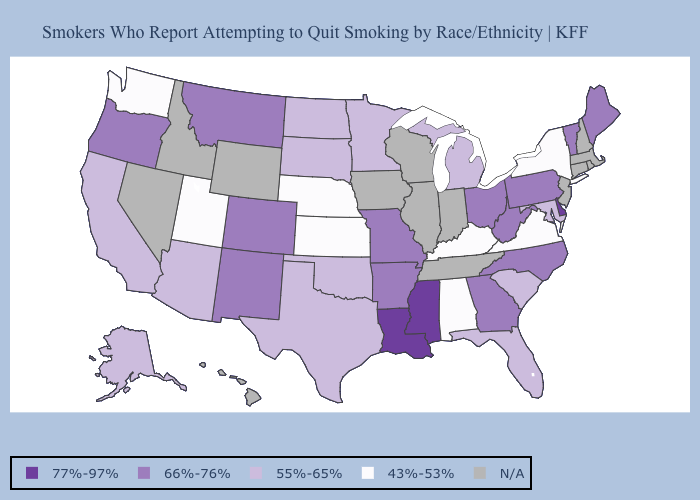Name the states that have a value in the range 66%-76%?
Answer briefly. Arkansas, Colorado, Georgia, Maine, Missouri, Montana, New Mexico, North Carolina, Ohio, Oregon, Pennsylvania, Vermont, West Virginia. Which states have the lowest value in the USA?
Keep it brief. Alabama, Kansas, Kentucky, Nebraska, New York, Utah, Virginia, Washington. Name the states that have a value in the range N/A?
Answer briefly. Connecticut, Hawaii, Idaho, Illinois, Indiana, Iowa, Massachusetts, Nevada, New Hampshire, New Jersey, Rhode Island, Tennessee, Wisconsin, Wyoming. What is the value of Florida?
Write a very short answer. 55%-65%. Which states have the lowest value in the MidWest?
Be succinct. Kansas, Nebraska. Among the states that border Oregon , which have the lowest value?
Give a very brief answer. Washington. What is the highest value in the Northeast ?
Keep it brief. 66%-76%. Does New York have the lowest value in the USA?
Short answer required. Yes. What is the value of Alabama?
Answer briefly. 43%-53%. Name the states that have a value in the range 43%-53%?
Answer briefly. Alabama, Kansas, Kentucky, Nebraska, New York, Utah, Virginia, Washington. Does Arizona have the lowest value in the West?
Be succinct. No. Name the states that have a value in the range 66%-76%?
Quick response, please. Arkansas, Colorado, Georgia, Maine, Missouri, Montana, New Mexico, North Carolina, Ohio, Oregon, Pennsylvania, Vermont, West Virginia. Among the states that border Maryland , does Delaware have the highest value?
Be succinct. Yes. Does Colorado have the lowest value in the USA?
Short answer required. No. 